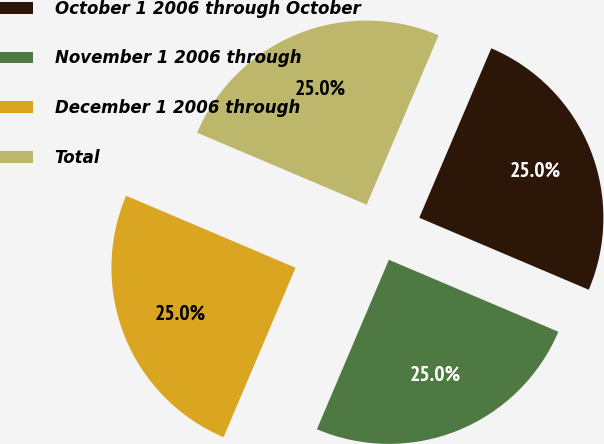Convert chart. <chart><loc_0><loc_0><loc_500><loc_500><pie_chart><fcel>October 1 2006 through October<fcel>November 1 2006 through<fcel>December 1 2006 through<fcel>Total<nl><fcel>25.0%<fcel>25.0%<fcel>25.0%<fcel>25.0%<nl></chart> 